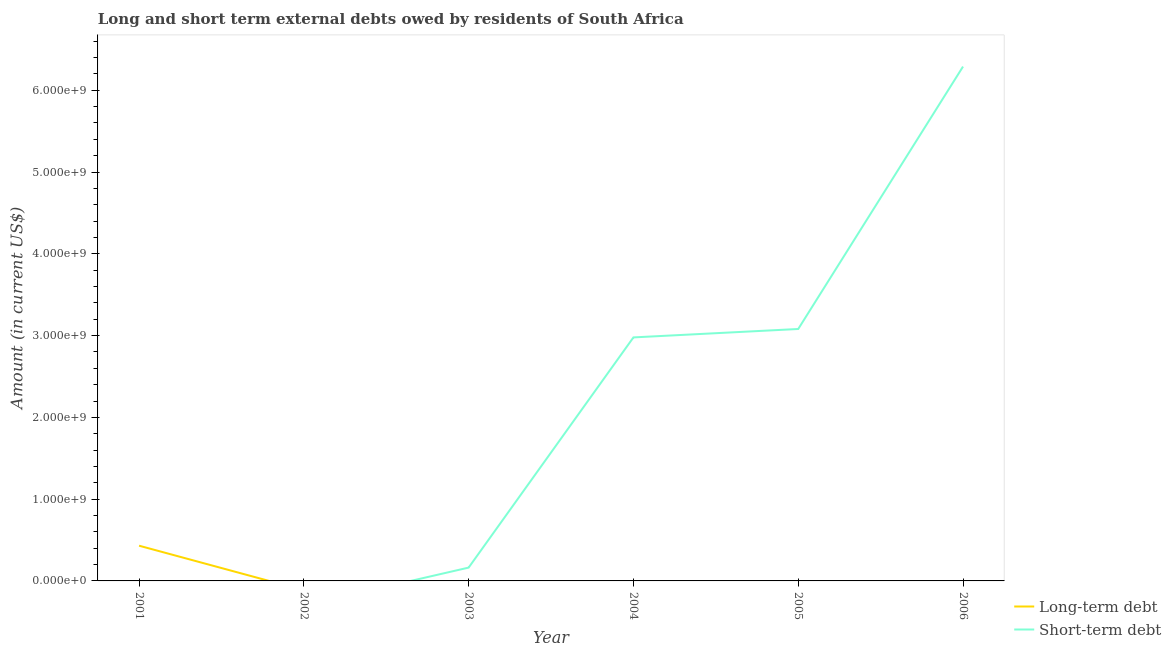Does the line corresponding to short-term debts owed by residents intersect with the line corresponding to long-term debts owed by residents?
Your response must be concise. Yes. Across all years, what is the maximum short-term debts owed by residents?
Provide a short and direct response. 6.29e+09. Across all years, what is the minimum long-term debts owed by residents?
Provide a succinct answer. 0. In which year was the long-term debts owed by residents maximum?
Make the answer very short. 2001. What is the total short-term debts owed by residents in the graph?
Offer a very short reply. 1.25e+1. What is the difference between the short-term debts owed by residents in 2005 and that in 2006?
Your response must be concise. -3.21e+09. What is the difference between the long-term debts owed by residents in 2005 and the short-term debts owed by residents in 2003?
Your response must be concise. -1.63e+08. What is the average long-term debts owed by residents per year?
Ensure brevity in your answer.  7.18e+07. What is the difference between the highest and the second highest short-term debts owed by residents?
Your response must be concise. 3.21e+09. What is the difference between the highest and the lowest short-term debts owed by residents?
Give a very brief answer. 6.29e+09. In how many years, is the short-term debts owed by residents greater than the average short-term debts owed by residents taken over all years?
Ensure brevity in your answer.  3. Is the sum of the short-term debts owed by residents in 2003 and 2006 greater than the maximum long-term debts owed by residents across all years?
Ensure brevity in your answer.  Yes. Does the short-term debts owed by residents monotonically increase over the years?
Your response must be concise. Yes. Is the long-term debts owed by residents strictly greater than the short-term debts owed by residents over the years?
Provide a succinct answer. No. How many lines are there?
Give a very brief answer. 2. Does the graph contain any zero values?
Offer a very short reply. Yes. Where does the legend appear in the graph?
Offer a terse response. Bottom right. How many legend labels are there?
Provide a succinct answer. 2. How are the legend labels stacked?
Ensure brevity in your answer.  Vertical. What is the title of the graph?
Offer a very short reply. Long and short term external debts owed by residents of South Africa. What is the label or title of the X-axis?
Make the answer very short. Year. What is the Amount (in current US$) of Long-term debt in 2001?
Ensure brevity in your answer.  4.31e+08. What is the Amount (in current US$) in Short-term debt in 2001?
Provide a succinct answer. 0. What is the Amount (in current US$) in Short-term debt in 2002?
Make the answer very short. 0. What is the Amount (in current US$) in Long-term debt in 2003?
Keep it short and to the point. 0. What is the Amount (in current US$) of Short-term debt in 2003?
Offer a very short reply. 1.63e+08. What is the Amount (in current US$) in Short-term debt in 2004?
Ensure brevity in your answer.  2.98e+09. What is the Amount (in current US$) in Short-term debt in 2005?
Offer a terse response. 3.08e+09. What is the Amount (in current US$) in Short-term debt in 2006?
Provide a succinct answer. 6.29e+09. Across all years, what is the maximum Amount (in current US$) of Long-term debt?
Your response must be concise. 4.31e+08. Across all years, what is the maximum Amount (in current US$) of Short-term debt?
Offer a very short reply. 6.29e+09. Across all years, what is the minimum Amount (in current US$) of Long-term debt?
Your answer should be very brief. 0. Across all years, what is the minimum Amount (in current US$) in Short-term debt?
Give a very brief answer. 0. What is the total Amount (in current US$) in Long-term debt in the graph?
Keep it short and to the point. 4.31e+08. What is the total Amount (in current US$) of Short-term debt in the graph?
Your answer should be compact. 1.25e+1. What is the difference between the Amount (in current US$) of Short-term debt in 2003 and that in 2004?
Ensure brevity in your answer.  -2.82e+09. What is the difference between the Amount (in current US$) of Short-term debt in 2003 and that in 2005?
Keep it short and to the point. -2.92e+09. What is the difference between the Amount (in current US$) in Short-term debt in 2003 and that in 2006?
Your answer should be very brief. -6.13e+09. What is the difference between the Amount (in current US$) of Short-term debt in 2004 and that in 2005?
Provide a succinct answer. -1.03e+08. What is the difference between the Amount (in current US$) in Short-term debt in 2004 and that in 2006?
Your answer should be compact. -3.31e+09. What is the difference between the Amount (in current US$) of Short-term debt in 2005 and that in 2006?
Your response must be concise. -3.21e+09. What is the difference between the Amount (in current US$) in Long-term debt in 2001 and the Amount (in current US$) in Short-term debt in 2003?
Your answer should be very brief. 2.68e+08. What is the difference between the Amount (in current US$) in Long-term debt in 2001 and the Amount (in current US$) in Short-term debt in 2004?
Provide a short and direct response. -2.55e+09. What is the difference between the Amount (in current US$) in Long-term debt in 2001 and the Amount (in current US$) in Short-term debt in 2005?
Make the answer very short. -2.65e+09. What is the difference between the Amount (in current US$) of Long-term debt in 2001 and the Amount (in current US$) of Short-term debt in 2006?
Your response must be concise. -5.86e+09. What is the average Amount (in current US$) in Long-term debt per year?
Keep it short and to the point. 7.18e+07. What is the average Amount (in current US$) in Short-term debt per year?
Make the answer very short. 2.09e+09. What is the ratio of the Amount (in current US$) of Short-term debt in 2003 to that in 2004?
Your answer should be very brief. 0.05. What is the ratio of the Amount (in current US$) of Short-term debt in 2003 to that in 2005?
Your response must be concise. 0.05. What is the ratio of the Amount (in current US$) of Short-term debt in 2003 to that in 2006?
Your response must be concise. 0.03. What is the ratio of the Amount (in current US$) of Short-term debt in 2004 to that in 2005?
Ensure brevity in your answer.  0.97. What is the ratio of the Amount (in current US$) of Short-term debt in 2004 to that in 2006?
Ensure brevity in your answer.  0.47. What is the ratio of the Amount (in current US$) of Short-term debt in 2005 to that in 2006?
Your answer should be compact. 0.49. What is the difference between the highest and the second highest Amount (in current US$) of Short-term debt?
Offer a very short reply. 3.21e+09. What is the difference between the highest and the lowest Amount (in current US$) in Long-term debt?
Offer a very short reply. 4.31e+08. What is the difference between the highest and the lowest Amount (in current US$) of Short-term debt?
Provide a short and direct response. 6.29e+09. 